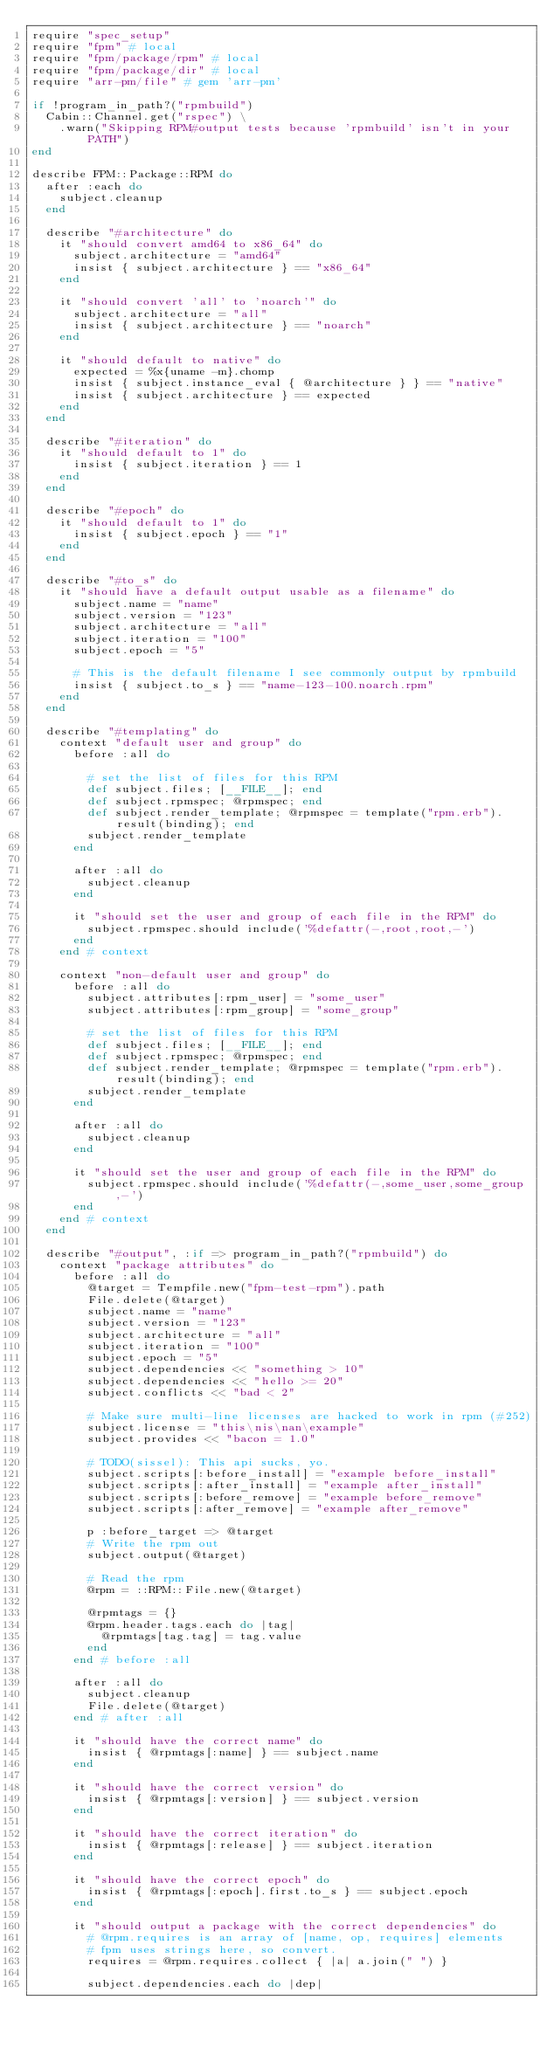Convert code to text. <code><loc_0><loc_0><loc_500><loc_500><_Ruby_>require "spec_setup"
require "fpm" # local
require "fpm/package/rpm" # local
require "fpm/package/dir" # local
require "arr-pm/file" # gem 'arr-pm'

if !program_in_path?("rpmbuild")
  Cabin::Channel.get("rspec") \
    .warn("Skipping RPM#output tests because 'rpmbuild' isn't in your PATH")
end

describe FPM::Package::RPM do
  after :each do
    subject.cleanup
  end

  describe "#architecture" do
    it "should convert amd64 to x86_64" do
      subject.architecture = "amd64"
      insist { subject.architecture } == "x86_64"
    end

    it "should convert 'all' to 'noarch'" do
      subject.architecture = "all"
      insist { subject.architecture } == "noarch"
    end

    it "should default to native" do
      expected = %x{uname -m}.chomp
      insist { subject.instance_eval { @architecture } } == "native"
      insist { subject.architecture } == expected
    end
  end

  describe "#iteration" do
    it "should default to 1" do
      insist { subject.iteration } == 1
    end
  end

  describe "#epoch" do
    it "should default to 1" do
      insist { subject.epoch } == "1"
    end
  end
  
  describe "#to_s" do
    it "should have a default output usable as a filename" do
      subject.name = "name"
      subject.version = "123"
      subject.architecture = "all"
      subject.iteration = "100"
      subject.epoch = "5"

      # This is the default filename I see commonly output by rpmbuild
      insist { subject.to_s } == "name-123-100.noarch.rpm"
    end
  end

  describe "#templating" do
    context "default user and group" do
      before :all do

        # set the list of files for this RPM
        def subject.files; [__FILE__]; end
        def subject.rpmspec; @rpmspec; end
        def subject.render_template; @rpmspec = template("rpm.erb").result(binding); end
        subject.render_template
      end

      after :all do
        subject.cleanup
      end

      it "should set the user and group of each file in the RPM" do
        subject.rpmspec.should include('%defattr(-,root,root,-')
      end
    end # context

    context "non-default user and group" do
      before :all do
        subject.attributes[:rpm_user] = "some_user"
        subject.attributes[:rpm_group] = "some_group"

        # set the list of files for this RPM
        def subject.files; [__FILE__]; end
        def subject.rpmspec; @rpmspec; end
        def subject.render_template; @rpmspec = template("rpm.erb").result(binding); end
        subject.render_template
      end

      after :all do
        subject.cleanup
      end

      it "should set the user and group of each file in the RPM" do
        subject.rpmspec.should include('%defattr(-,some_user,some_group,-')
      end
    end # context
  end

  describe "#output", :if => program_in_path?("rpmbuild") do
    context "package attributes" do
      before :all do
        @target = Tempfile.new("fpm-test-rpm").path
        File.delete(@target)
        subject.name = "name"
        subject.version = "123"
        subject.architecture = "all"
        subject.iteration = "100"
        subject.epoch = "5"
        subject.dependencies << "something > 10"
        subject.dependencies << "hello >= 20"
        subject.conflicts << "bad < 2"

        # Make sure multi-line licenses are hacked to work in rpm (#252)
        subject.license = "this\nis\nan\example"
        subject.provides << "bacon = 1.0"

        # TODO(sissel): This api sucks, yo.
        subject.scripts[:before_install] = "example before_install"
        subject.scripts[:after_install] = "example after_install"
        subject.scripts[:before_remove] = "example before_remove"
        subject.scripts[:after_remove] = "example after_remove"

        p :before_target => @target
        # Write the rpm out
        subject.output(@target)

        # Read the rpm
        @rpm = ::RPM::File.new(@target)

        @rpmtags = {}
        @rpm.header.tags.each do |tag|
          @rpmtags[tag.tag] = tag.value
        end
      end # before :all

      after :all do
        subject.cleanup
        File.delete(@target)
      end # after :all

      it "should have the correct name" do
        insist { @rpmtags[:name] } == subject.name
      end

      it "should have the correct version" do
        insist { @rpmtags[:version] } == subject.version
      end

      it "should have the correct iteration" do
        insist { @rpmtags[:release] } == subject.iteration
      end

      it "should have the correct epoch" do
        insist { @rpmtags[:epoch].first.to_s } == subject.epoch
      end

      it "should output a package with the correct dependencies" do
        # @rpm.requires is an array of [name, op, requires] elements
        # fpm uses strings here, so convert.
        requires = @rpm.requires.collect { |a| a.join(" ") }

        subject.dependencies.each do |dep|</code> 